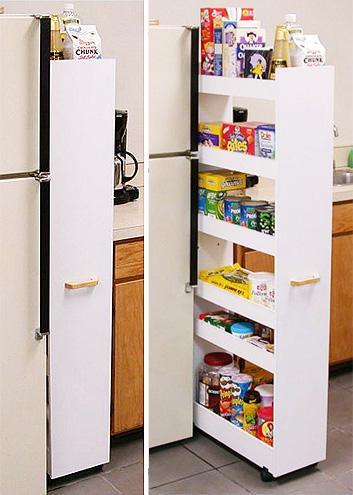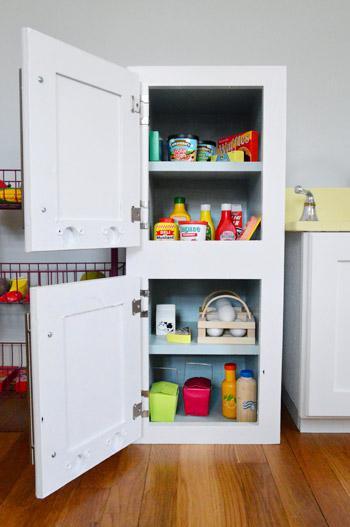The first image is the image on the left, the second image is the image on the right. Analyze the images presented: Is the assertion "A narrow white pantry with filled shelves is extended out alongside a white refrigerator with no magnets on it, in the left image." valid? Answer yes or no. Yes. The first image is the image on the left, the second image is the image on the right. For the images shown, is this caption "At least one shelving unit is used as behind the fridge pantry space." true? Answer yes or no. Yes. 